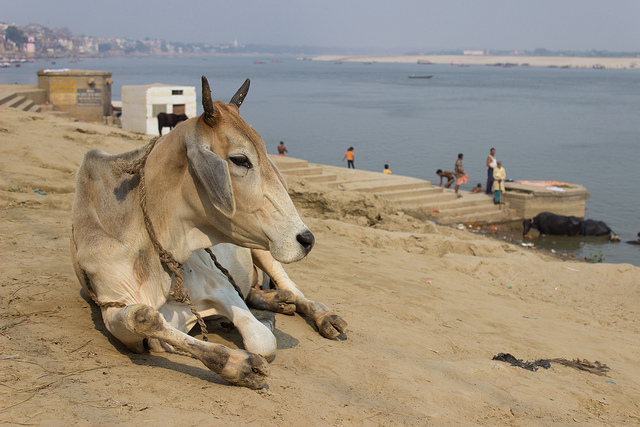<image>Was this photograph taken in America? It is ambiguous if the photograph was taken in America. Was this photograph taken in America? I don't know if this photograph was taken in America. It is uncertain. 